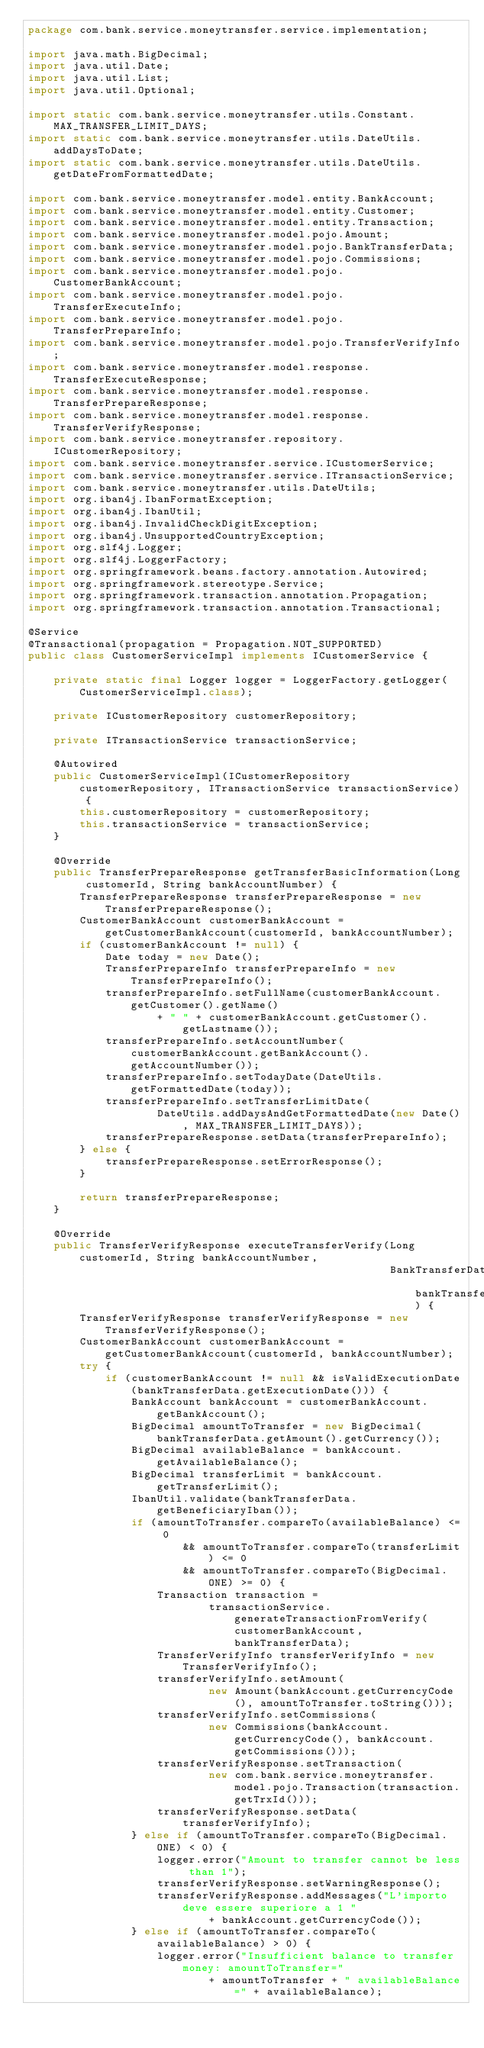<code> <loc_0><loc_0><loc_500><loc_500><_Java_>package com.bank.service.moneytransfer.service.implementation;

import java.math.BigDecimal;
import java.util.Date;
import java.util.List;
import java.util.Optional;

import static com.bank.service.moneytransfer.utils.Constant.MAX_TRANSFER_LIMIT_DAYS;
import static com.bank.service.moneytransfer.utils.DateUtils.addDaysToDate;
import static com.bank.service.moneytransfer.utils.DateUtils.getDateFromFormattedDate;

import com.bank.service.moneytransfer.model.entity.BankAccount;
import com.bank.service.moneytransfer.model.entity.Customer;
import com.bank.service.moneytransfer.model.entity.Transaction;
import com.bank.service.moneytransfer.model.pojo.Amount;
import com.bank.service.moneytransfer.model.pojo.BankTransferData;
import com.bank.service.moneytransfer.model.pojo.Commissions;
import com.bank.service.moneytransfer.model.pojo.CustomerBankAccount;
import com.bank.service.moneytransfer.model.pojo.TransferExecuteInfo;
import com.bank.service.moneytransfer.model.pojo.TransferPrepareInfo;
import com.bank.service.moneytransfer.model.pojo.TransferVerifyInfo;
import com.bank.service.moneytransfer.model.response.TransferExecuteResponse;
import com.bank.service.moneytransfer.model.response.TransferPrepareResponse;
import com.bank.service.moneytransfer.model.response.TransferVerifyResponse;
import com.bank.service.moneytransfer.repository.ICustomerRepository;
import com.bank.service.moneytransfer.service.ICustomerService;
import com.bank.service.moneytransfer.service.ITransactionService;
import com.bank.service.moneytransfer.utils.DateUtils;
import org.iban4j.IbanFormatException;
import org.iban4j.IbanUtil;
import org.iban4j.InvalidCheckDigitException;
import org.iban4j.UnsupportedCountryException;
import org.slf4j.Logger;
import org.slf4j.LoggerFactory;
import org.springframework.beans.factory.annotation.Autowired;
import org.springframework.stereotype.Service;
import org.springframework.transaction.annotation.Propagation;
import org.springframework.transaction.annotation.Transactional;

@Service
@Transactional(propagation = Propagation.NOT_SUPPORTED)
public class CustomerServiceImpl implements ICustomerService {

    private static final Logger logger = LoggerFactory.getLogger(CustomerServiceImpl.class);

    private ICustomerRepository customerRepository;

    private ITransactionService transactionService;

    @Autowired
    public CustomerServiceImpl(ICustomerRepository customerRepository, ITransactionService transactionService) {
        this.customerRepository = customerRepository;
        this.transactionService = transactionService;
    }

    @Override
    public TransferPrepareResponse getTransferBasicInformation(Long customerId, String bankAccountNumber) {
        TransferPrepareResponse transferPrepareResponse = new TransferPrepareResponse();
        CustomerBankAccount customerBankAccount = getCustomerBankAccount(customerId, bankAccountNumber);
        if (customerBankAccount != null) {
            Date today = new Date();
            TransferPrepareInfo transferPrepareInfo = new TransferPrepareInfo();
            transferPrepareInfo.setFullName(customerBankAccount.getCustomer().getName()
                    + " " + customerBankAccount.getCustomer().getLastname());
            transferPrepareInfo.setAccountNumber(customerBankAccount.getBankAccount().getAccountNumber());
            transferPrepareInfo.setTodayDate(DateUtils.getFormattedDate(today));
            transferPrepareInfo.setTransferLimitDate(
                    DateUtils.addDaysAndGetFormattedDate(new Date(), MAX_TRANSFER_LIMIT_DAYS));
            transferPrepareResponse.setData(transferPrepareInfo);
        } else {
            transferPrepareResponse.setErrorResponse();
        }

        return transferPrepareResponse;
    }

    @Override
    public TransferVerifyResponse executeTransferVerify(Long customerId, String bankAccountNumber,
                                                        BankTransferData bankTransferData) {
        TransferVerifyResponse transferVerifyResponse = new TransferVerifyResponse();
        CustomerBankAccount customerBankAccount = getCustomerBankAccount(customerId, bankAccountNumber);
        try {
            if (customerBankAccount != null && isValidExecutionDate(bankTransferData.getExecutionDate())) {
                BankAccount bankAccount = customerBankAccount.getBankAccount();
                BigDecimal amountToTransfer = new BigDecimal(bankTransferData.getAmount().getCurrency());
                BigDecimal availableBalance = bankAccount.getAvailableBalance();
                BigDecimal transferLimit = bankAccount.getTransferLimit();
                IbanUtil.validate(bankTransferData.getBeneficiaryIban());
                if (amountToTransfer.compareTo(availableBalance) <= 0
                        && amountToTransfer.compareTo(transferLimit) <= 0
                        && amountToTransfer.compareTo(BigDecimal.ONE) >= 0) {
                    Transaction transaction =
                            transactionService.generateTransactionFromVerify(customerBankAccount, bankTransferData);
                    TransferVerifyInfo transferVerifyInfo = new TransferVerifyInfo();
                    transferVerifyInfo.setAmount(
                            new Amount(bankAccount.getCurrencyCode(), amountToTransfer.toString()));
                    transferVerifyInfo.setCommissions(
                            new Commissions(bankAccount.getCurrencyCode(), bankAccount.getCommissions()));
                    transferVerifyResponse.setTransaction(
                            new com.bank.service.moneytransfer.model.pojo.Transaction(transaction.getTrxId()));
                    transferVerifyResponse.setData(transferVerifyInfo);
                } else if (amountToTransfer.compareTo(BigDecimal.ONE) < 0) {
                    logger.error("Amount to transfer cannot be less than 1");
                    transferVerifyResponse.setWarningResponse();
                    transferVerifyResponse.addMessages("L'importo deve essere superiore a 1 "
                            + bankAccount.getCurrencyCode());
                } else if (amountToTransfer.compareTo(availableBalance) > 0) {
                    logger.error("Insufficient balance to transfer money: amountToTransfer="
                            + amountToTransfer + " availableBalance=" + availableBalance);</code> 